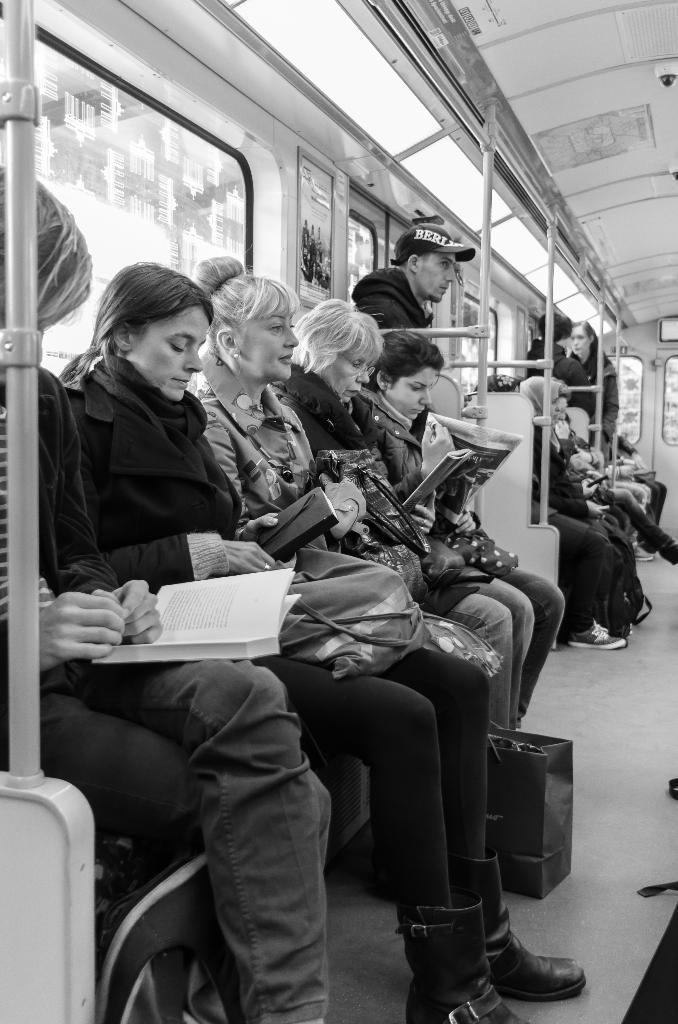Please provide a concise description of this image. In this image few persons are sitting on the seats, which are inside the vehicle. Left side a person is having a book on his lap. Beside there is a woman holding a purse and she is having a bag on her lap. A person is standing behind the metal rods. Background there are few windows. A bag is on the floor. 